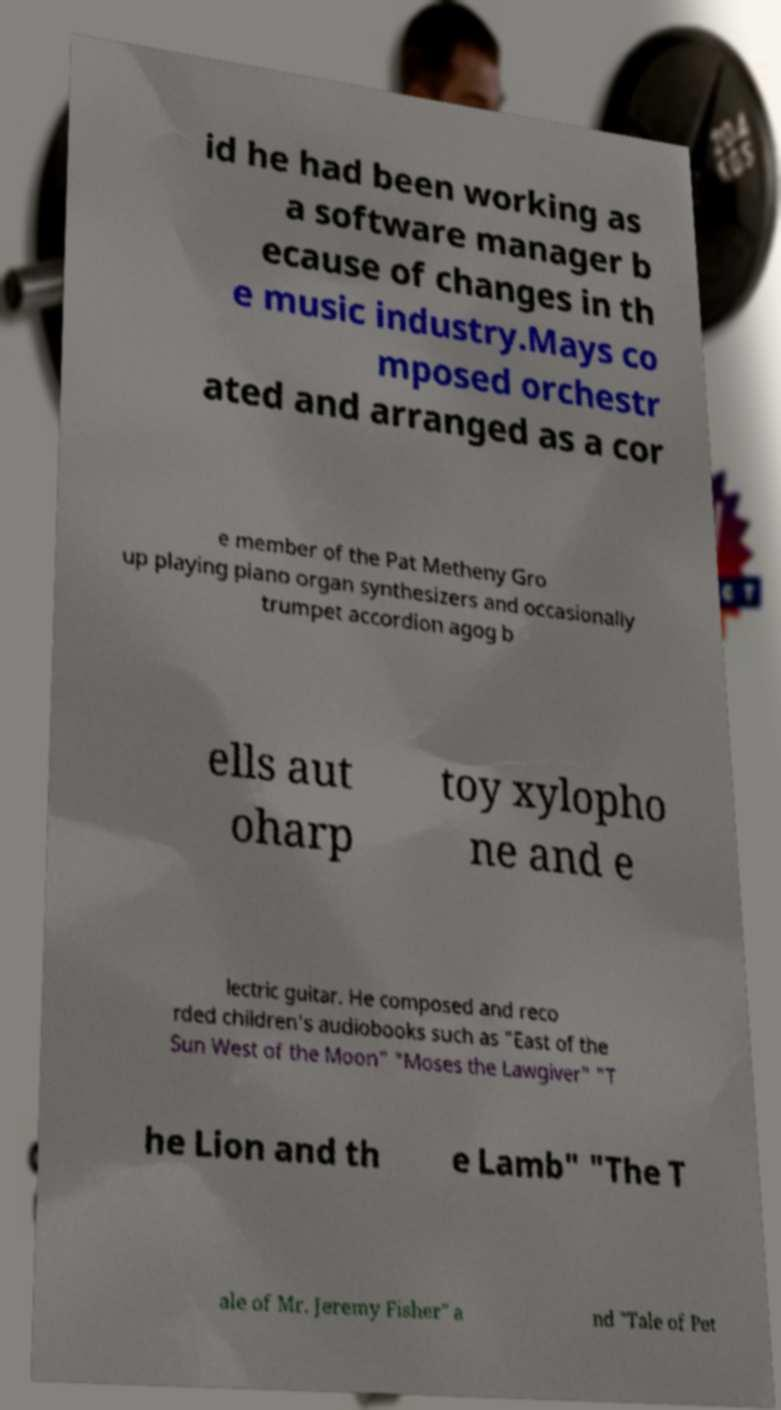For documentation purposes, I need the text within this image transcribed. Could you provide that? id he had been working as a software manager b ecause of changes in th e music industry.Mays co mposed orchestr ated and arranged as a cor e member of the Pat Metheny Gro up playing piano organ synthesizers and occasionally trumpet accordion agog b ells aut oharp toy xylopho ne and e lectric guitar. He composed and reco rded children's audiobooks such as "East of the Sun West of the Moon" "Moses the Lawgiver" "T he Lion and th e Lamb" "The T ale of Mr. Jeremy Fisher" a nd "Tale of Pet 